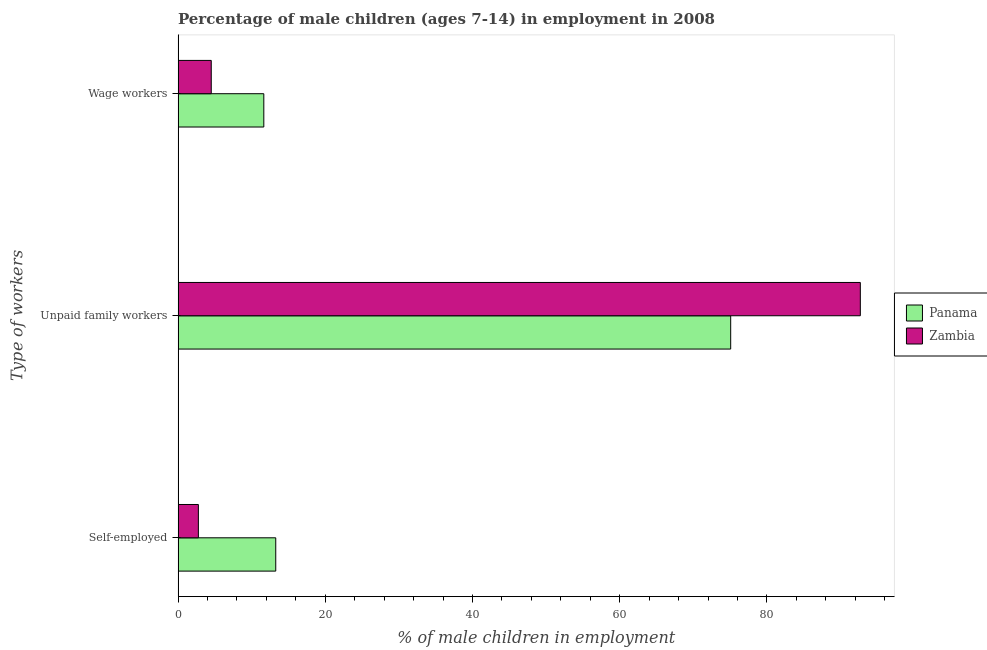Are the number of bars on each tick of the Y-axis equal?
Your response must be concise. Yes. How many bars are there on the 3rd tick from the bottom?
Your response must be concise. 2. What is the label of the 3rd group of bars from the top?
Give a very brief answer. Self-employed. What is the percentage of children employed as unpaid family workers in Zambia?
Your answer should be compact. 92.68. Across all countries, what is the maximum percentage of children employed as unpaid family workers?
Offer a very short reply. 92.68. Across all countries, what is the minimum percentage of children employed as wage workers?
Keep it short and to the point. 4.51. In which country was the percentage of children employed as wage workers maximum?
Provide a succinct answer. Panama. In which country was the percentage of children employed as unpaid family workers minimum?
Provide a succinct answer. Panama. What is the total percentage of self employed children in the graph?
Provide a succinct answer. 16.03. What is the difference between the percentage of children employed as wage workers in Zambia and that in Panama?
Make the answer very short. -7.14. What is the difference between the percentage of children employed as unpaid family workers in Zambia and the percentage of children employed as wage workers in Panama?
Provide a short and direct response. 81.03. What is the average percentage of children employed as wage workers per country?
Offer a very short reply. 8.08. What is the difference between the percentage of children employed as unpaid family workers and percentage of self employed children in Zambia?
Your answer should be very brief. 89.92. In how many countries, is the percentage of self employed children greater than 56 %?
Keep it short and to the point. 0. What is the ratio of the percentage of children employed as wage workers in Zambia to that in Panama?
Your answer should be very brief. 0.39. What is the difference between the highest and the second highest percentage of children employed as unpaid family workers?
Give a very brief answer. 17.61. What is the difference between the highest and the lowest percentage of children employed as unpaid family workers?
Provide a succinct answer. 17.61. In how many countries, is the percentage of self employed children greater than the average percentage of self employed children taken over all countries?
Make the answer very short. 1. What does the 2nd bar from the top in Unpaid family workers represents?
Your response must be concise. Panama. What does the 1st bar from the bottom in Unpaid family workers represents?
Provide a short and direct response. Panama. How many countries are there in the graph?
Ensure brevity in your answer.  2. Are the values on the major ticks of X-axis written in scientific E-notation?
Provide a short and direct response. No. Does the graph contain grids?
Make the answer very short. No. What is the title of the graph?
Provide a succinct answer. Percentage of male children (ages 7-14) in employment in 2008. Does "Kyrgyz Republic" appear as one of the legend labels in the graph?
Your answer should be compact. No. What is the label or title of the X-axis?
Your answer should be compact. % of male children in employment. What is the label or title of the Y-axis?
Your response must be concise. Type of workers. What is the % of male children in employment in Panama in Self-employed?
Keep it short and to the point. 13.27. What is the % of male children in employment of Zambia in Self-employed?
Ensure brevity in your answer.  2.76. What is the % of male children in employment in Panama in Unpaid family workers?
Offer a very short reply. 75.07. What is the % of male children in employment of Zambia in Unpaid family workers?
Give a very brief answer. 92.68. What is the % of male children in employment in Panama in Wage workers?
Make the answer very short. 11.65. What is the % of male children in employment in Zambia in Wage workers?
Your answer should be compact. 4.51. Across all Type of workers, what is the maximum % of male children in employment in Panama?
Offer a terse response. 75.07. Across all Type of workers, what is the maximum % of male children in employment of Zambia?
Offer a terse response. 92.68. Across all Type of workers, what is the minimum % of male children in employment in Panama?
Provide a succinct answer. 11.65. Across all Type of workers, what is the minimum % of male children in employment in Zambia?
Give a very brief answer. 2.76. What is the total % of male children in employment in Panama in the graph?
Keep it short and to the point. 99.99. What is the total % of male children in employment of Zambia in the graph?
Give a very brief answer. 99.95. What is the difference between the % of male children in employment in Panama in Self-employed and that in Unpaid family workers?
Ensure brevity in your answer.  -61.8. What is the difference between the % of male children in employment of Zambia in Self-employed and that in Unpaid family workers?
Give a very brief answer. -89.92. What is the difference between the % of male children in employment of Panama in Self-employed and that in Wage workers?
Make the answer very short. 1.62. What is the difference between the % of male children in employment in Zambia in Self-employed and that in Wage workers?
Your answer should be compact. -1.75. What is the difference between the % of male children in employment of Panama in Unpaid family workers and that in Wage workers?
Keep it short and to the point. 63.42. What is the difference between the % of male children in employment of Zambia in Unpaid family workers and that in Wage workers?
Provide a succinct answer. 88.17. What is the difference between the % of male children in employment of Panama in Self-employed and the % of male children in employment of Zambia in Unpaid family workers?
Your answer should be compact. -79.41. What is the difference between the % of male children in employment in Panama in Self-employed and the % of male children in employment in Zambia in Wage workers?
Make the answer very short. 8.76. What is the difference between the % of male children in employment in Panama in Unpaid family workers and the % of male children in employment in Zambia in Wage workers?
Provide a short and direct response. 70.56. What is the average % of male children in employment in Panama per Type of workers?
Your answer should be very brief. 33.33. What is the average % of male children in employment of Zambia per Type of workers?
Offer a very short reply. 33.32. What is the difference between the % of male children in employment in Panama and % of male children in employment in Zambia in Self-employed?
Your response must be concise. 10.51. What is the difference between the % of male children in employment in Panama and % of male children in employment in Zambia in Unpaid family workers?
Provide a short and direct response. -17.61. What is the difference between the % of male children in employment of Panama and % of male children in employment of Zambia in Wage workers?
Your answer should be very brief. 7.14. What is the ratio of the % of male children in employment in Panama in Self-employed to that in Unpaid family workers?
Provide a succinct answer. 0.18. What is the ratio of the % of male children in employment in Zambia in Self-employed to that in Unpaid family workers?
Make the answer very short. 0.03. What is the ratio of the % of male children in employment of Panama in Self-employed to that in Wage workers?
Your response must be concise. 1.14. What is the ratio of the % of male children in employment of Zambia in Self-employed to that in Wage workers?
Your response must be concise. 0.61. What is the ratio of the % of male children in employment of Panama in Unpaid family workers to that in Wage workers?
Offer a very short reply. 6.44. What is the ratio of the % of male children in employment in Zambia in Unpaid family workers to that in Wage workers?
Your answer should be compact. 20.55. What is the difference between the highest and the second highest % of male children in employment in Panama?
Your answer should be compact. 61.8. What is the difference between the highest and the second highest % of male children in employment in Zambia?
Offer a terse response. 88.17. What is the difference between the highest and the lowest % of male children in employment in Panama?
Make the answer very short. 63.42. What is the difference between the highest and the lowest % of male children in employment in Zambia?
Your answer should be very brief. 89.92. 